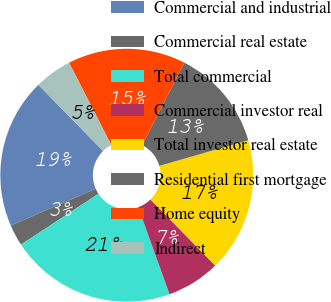Convert chart to OTSL. <chart><loc_0><loc_0><loc_500><loc_500><pie_chart><fcel>Commercial and industrial<fcel>Commercial real estate<fcel>Total commercial<fcel>Commercial investor real<fcel>Total investor real estate<fcel>Residential first mortgage<fcel>Home equity<fcel>Indirect<nl><fcel>19.19%<fcel>2.72%<fcel>21.25%<fcel>6.84%<fcel>17.13%<fcel>13.01%<fcel>15.07%<fcel>4.78%<nl></chart> 